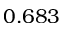Convert formula to latex. <formula><loc_0><loc_0><loc_500><loc_500>0 . 6 8 3</formula> 